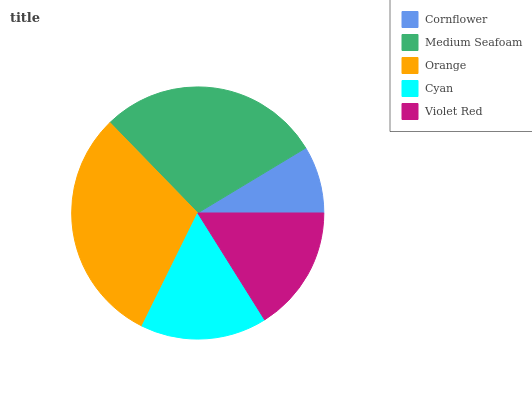Is Cornflower the minimum?
Answer yes or no. Yes. Is Orange the maximum?
Answer yes or no. Yes. Is Medium Seafoam the minimum?
Answer yes or no. No. Is Medium Seafoam the maximum?
Answer yes or no. No. Is Medium Seafoam greater than Cornflower?
Answer yes or no. Yes. Is Cornflower less than Medium Seafoam?
Answer yes or no. Yes. Is Cornflower greater than Medium Seafoam?
Answer yes or no. No. Is Medium Seafoam less than Cornflower?
Answer yes or no. No. Is Cyan the high median?
Answer yes or no. Yes. Is Cyan the low median?
Answer yes or no. Yes. Is Cornflower the high median?
Answer yes or no. No. Is Orange the low median?
Answer yes or no. No. 